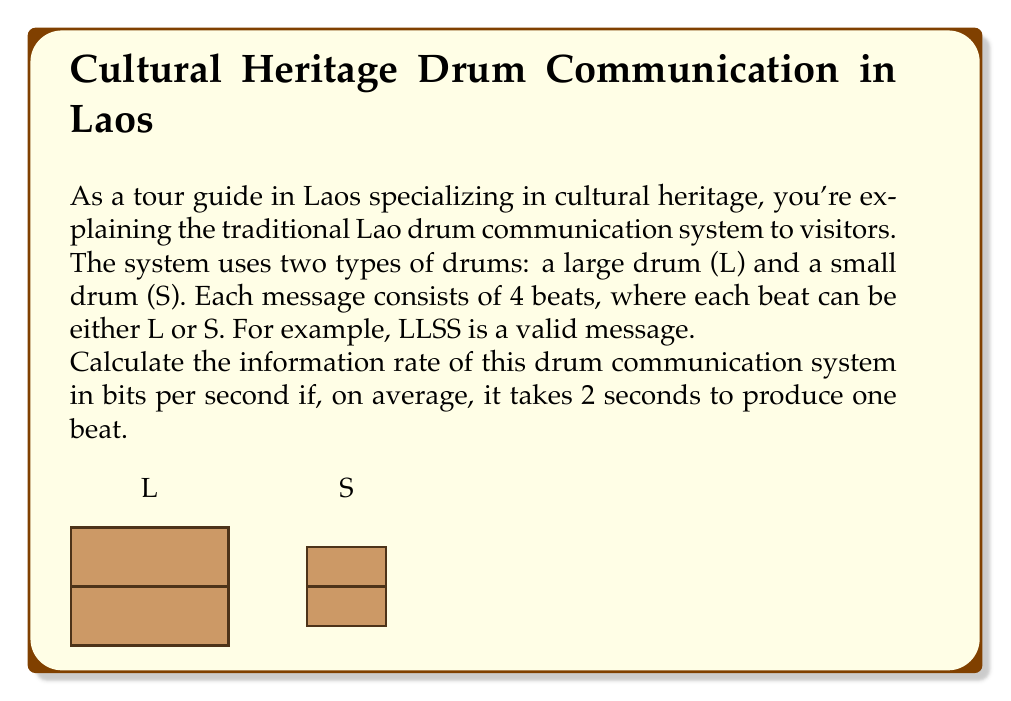What is the answer to this math problem? Let's approach this step-by-step:

1) First, we need to calculate the number of possible messages in this system.
   - Each message consists of 4 beats
   - Each beat can be either L or S
   - This is equivalent to a binary system with 4 digits
   - The number of possible messages is therefore $2^4 = 16$

2) Now, we can calculate the information content of each message:
   $I = \log_2(16) = 4$ bits

3) To find the information rate, we need to know how long it takes to transmit one message:
   - Each beat takes 2 seconds
   - A message consists of 4 beats
   - So, a complete message takes $4 * 2 = 8$ seconds

4) The information rate is the amount of information divided by the time taken:
   
   $$\text{Information Rate} = \frac{\text{Information Content}}{\text{Time}}$$

   $$\text{Information Rate} = \frac{4 \text{ bits}}{8 \text{ seconds}} = 0.5 \text{ bits/second}$$

Therefore, the information rate of this traditional Laotian drum communication system is 0.5 bits per second.
Answer: 0.5 bits/second 